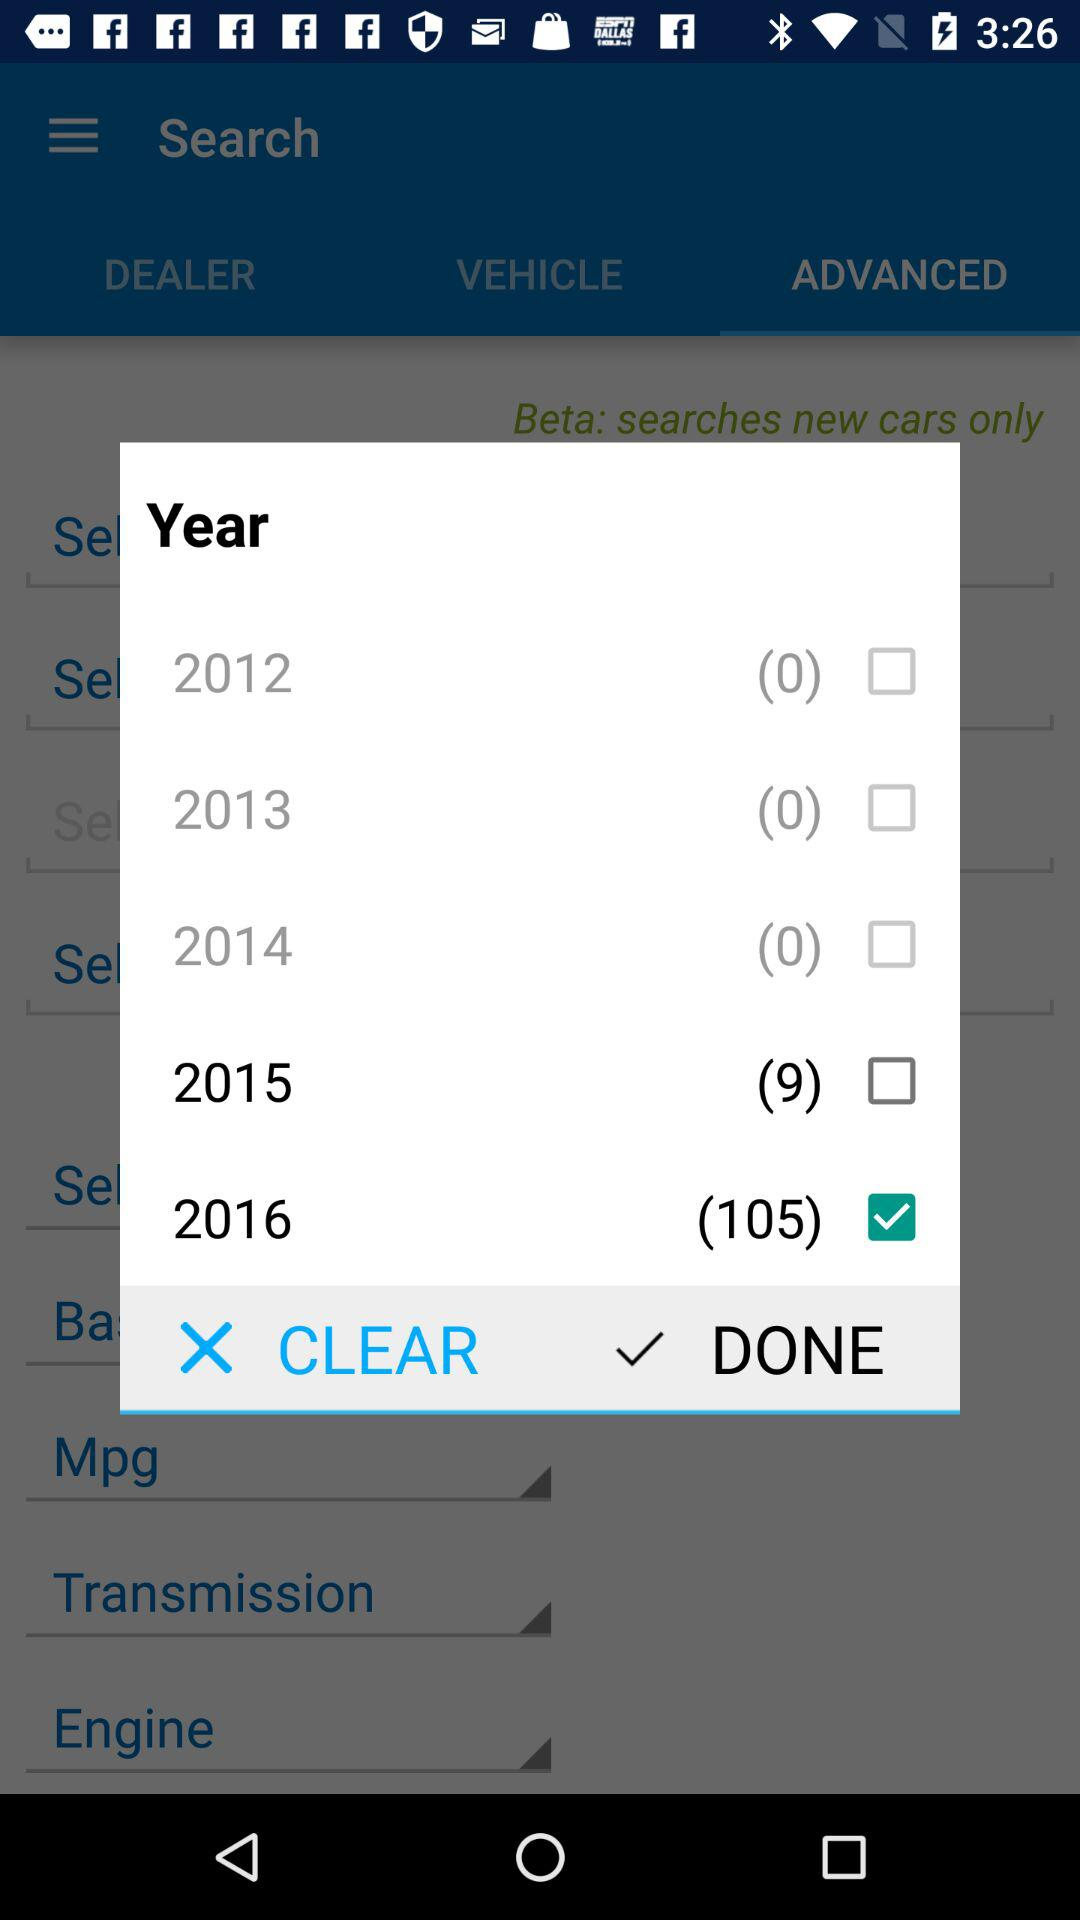How many visits are there for 2015?
Answer the question using a single word or phrase. 9 